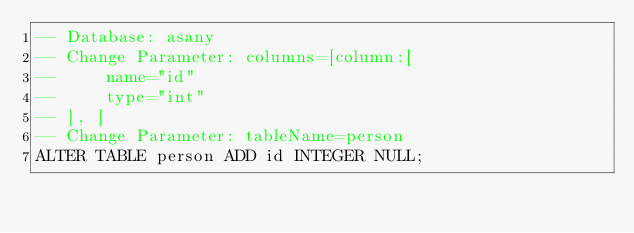Convert code to text. <code><loc_0><loc_0><loc_500><loc_500><_SQL_>-- Database: asany
-- Change Parameter: columns=[column:[
--     name="id"
--     type="int"
-- ], ]
-- Change Parameter: tableName=person
ALTER TABLE person ADD id INTEGER NULL;
</code> 